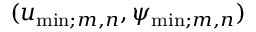Convert formula to latex. <formula><loc_0><loc_0><loc_500><loc_500>( u _ { \min ; m , n } , \psi _ { \min ; m , n } )</formula> 